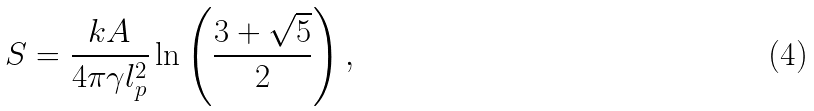Convert formula to latex. <formula><loc_0><loc_0><loc_500><loc_500>S = \frac { k A } { 4 \pi \gamma l _ { p } ^ { 2 } } \ln \left ( \frac { 3 + \sqrt { 5 } } { 2 } \right ) ,</formula> 